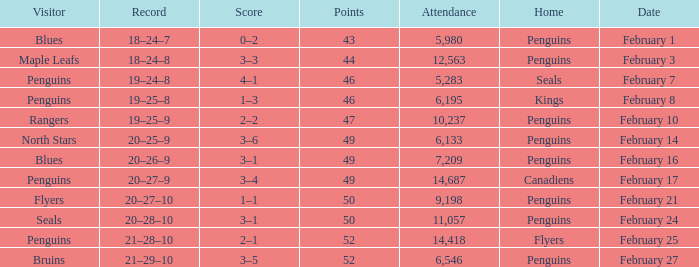Parse the full table. {'header': ['Visitor', 'Record', 'Score', 'Points', 'Attendance', 'Home', 'Date'], 'rows': [['Blues', '18–24–7', '0–2', '43', '5,980', 'Penguins', 'February 1'], ['Maple Leafs', '18–24–8', '3–3', '44', '12,563', 'Penguins', 'February 3'], ['Penguins', '19–24–8', '4–1', '46', '5,283', 'Seals', 'February 7'], ['Penguins', '19–25–8', '1–3', '46', '6,195', 'Kings', 'February 8'], ['Rangers', '19–25–9', '2–2', '47', '10,237', 'Penguins', 'February 10'], ['North Stars', '20–25–9', '3–6', '49', '6,133', 'Penguins', 'February 14'], ['Blues', '20–26–9', '3–1', '49', '7,209', 'Penguins', 'February 16'], ['Penguins', '20–27–9', '3–4', '49', '14,687', 'Canadiens', 'February 17'], ['Flyers', '20–27–10', '1–1', '50', '9,198', 'Penguins', 'February 21'], ['Seals', '20–28–10', '3–1', '50', '11,057', 'Penguins', 'February 24'], ['Penguins', '21–28–10', '2–1', '52', '14,418', 'Flyers', 'February 25'], ['Bruins', '21–29–10', '3–5', '52', '6,546', 'Penguins', 'February 27']]} Home of kings had what score? 1–3. 